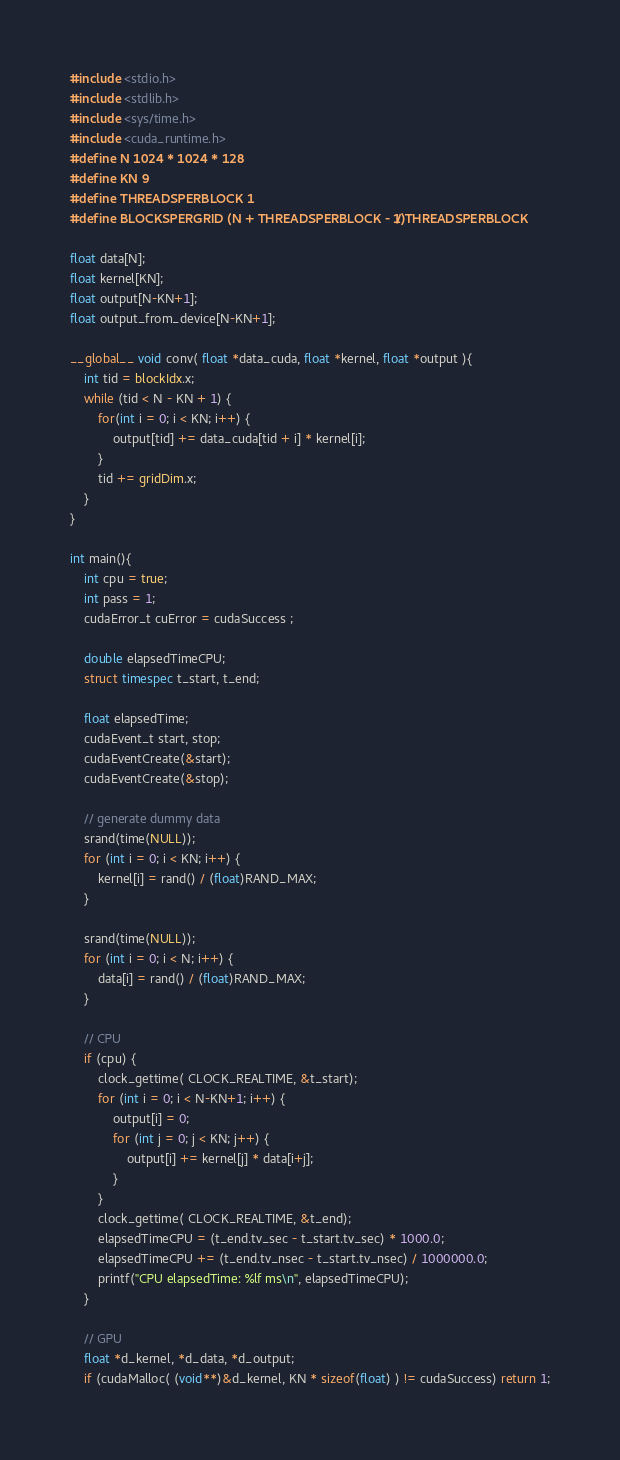<code> <loc_0><loc_0><loc_500><loc_500><_Cuda_>#include <stdio.h>
#include <stdlib.h>
#include <sys/time.h>
#include <cuda_runtime.h>
#define N 1024 * 1024 * 128
#define KN 9
#define THREADSPERBLOCK 1
#define BLOCKSPERGRID (N + THREADSPERBLOCK - 1) / THREADSPERBLOCK

float data[N];
float kernel[KN];
float output[N-KN+1];
float output_from_device[N-KN+1];

__global__ void conv( float *data_cuda, float *kernel, float *output ){
    int tid = blockIdx.x;
    while (tid < N - KN + 1) {
        for(int i = 0; i < KN; i++) {
            output[tid] += data_cuda[tid + i] * kernel[i];
        }
        tid += gridDim.x;
    }
}

int main(){
    int cpu = true;
    int pass = 1;
    cudaError_t cuError = cudaSuccess ;

    double elapsedTimeCPU;
    struct timespec t_start, t_end;
    
    float elapsedTime;
    cudaEvent_t start, stop;
    cudaEventCreate(&start);
    cudaEventCreate(&stop);

    // generate dummy data
    srand(time(NULL));
    for (int i = 0; i < KN; i++) {
        kernel[i] = rand() / (float)RAND_MAX;
    }
    
    srand(time(NULL));
    for (int i = 0; i < N; i++) {
        data[i] = rand() / (float)RAND_MAX;
    }

    // CPU
    if (cpu) {
        clock_gettime( CLOCK_REALTIME, &t_start);
        for (int i = 0; i < N-KN+1; i++) {
            output[i] = 0;
            for (int j = 0; j < KN; j++) {
                output[i] += kernel[j] * data[i+j];
            }
        }
        clock_gettime( CLOCK_REALTIME, &t_end);
        elapsedTimeCPU = (t_end.tv_sec - t_start.tv_sec) * 1000.0;
        elapsedTimeCPU += (t_end.tv_nsec - t_start.tv_nsec) / 1000000.0;
        printf("CPU elapsedTime: %lf ms\n", elapsedTimeCPU);
    }

    // GPU
    float *d_kernel, *d_data, *d_output;
    if (cudaMalloc( (void**)&d_kernel, KN * sizeof(float) ) != cudaSuccess) return 1;</code> 